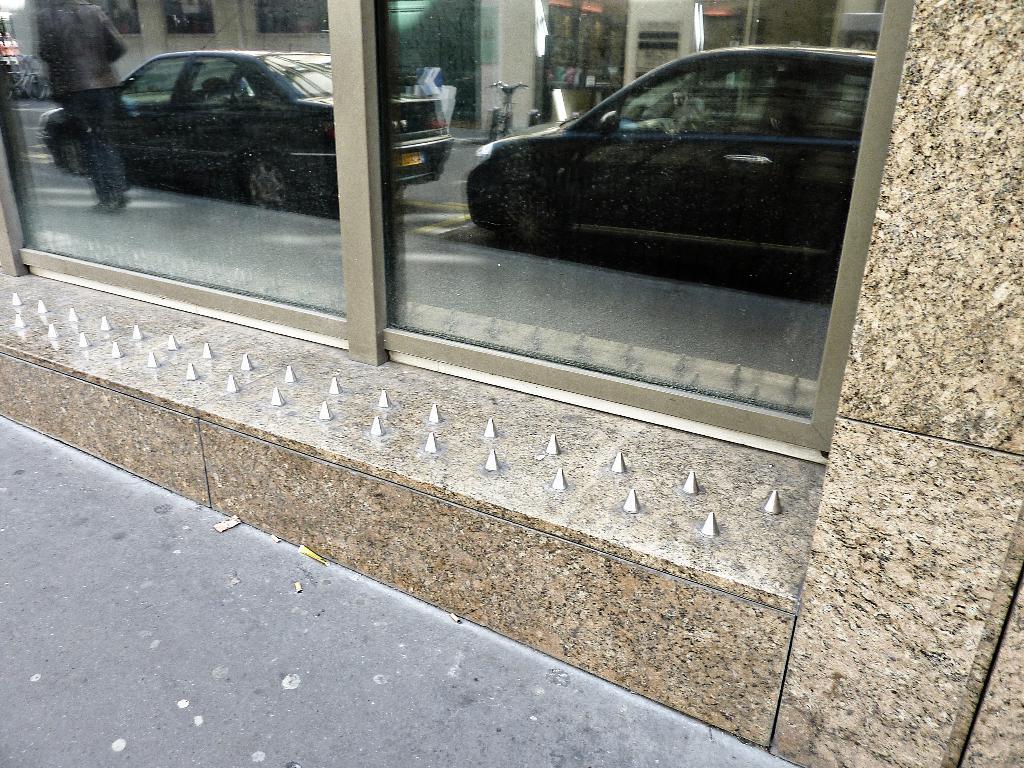Please provide a concise description of this image. In this image we can see the glasses of the building. We can see the reflection of few vehicles, few buildings and a person and many objects in the image. 